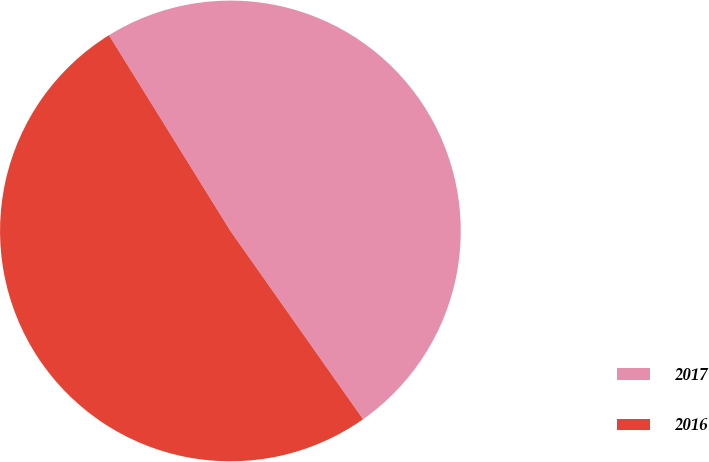<chart> <loc_0><loc_0><loc_500><loc_500><pie_chart><fcel>2017<fcel>2016<nl><fcel>49.07%<fcel>50.93%<nl></chart> 